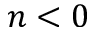<formula> <loc_0><loc_0><loc_500><loc_500>n < 0</formula> 